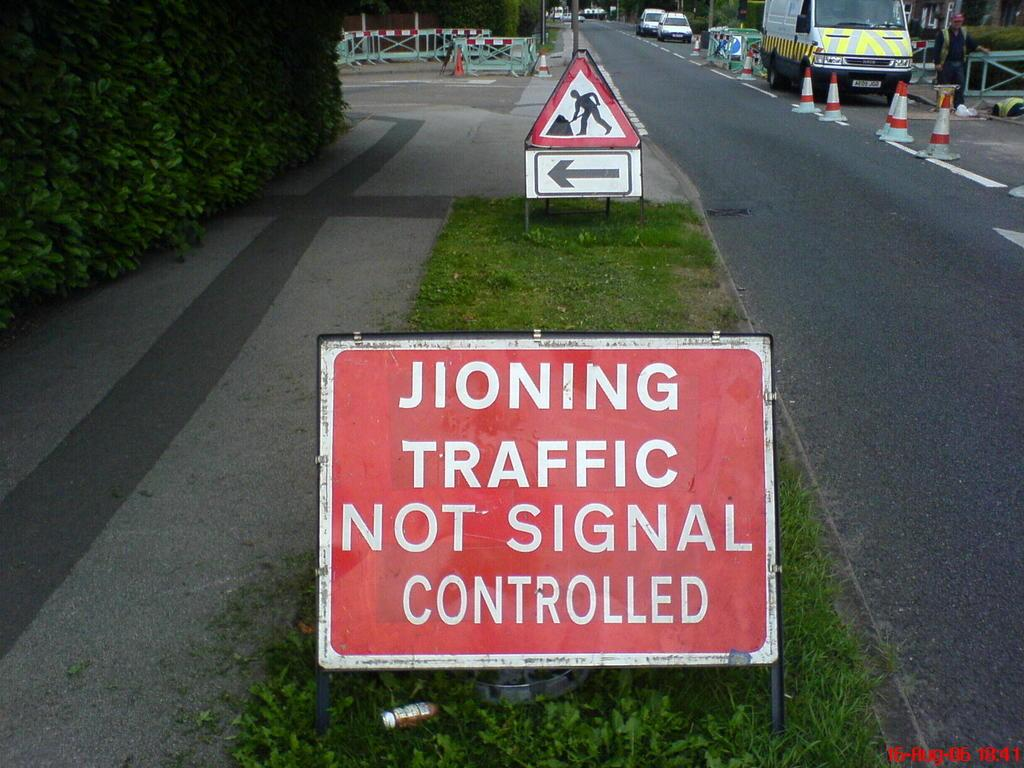<image>
Write a terse but informative summary of the picture. a jioning traffic sign on the grass outside 